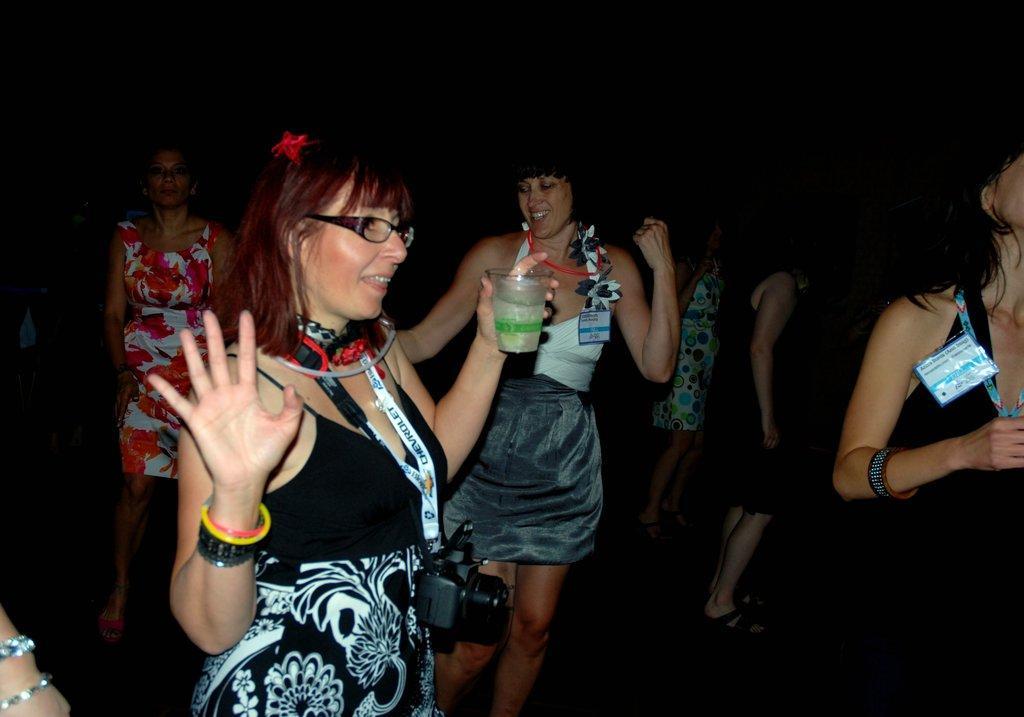Can you describe this image briefly? In this image I can see the group of people with different color dresses. I can see one person wearing the camera and specs. She is also holding the glass. And there is a black background. 